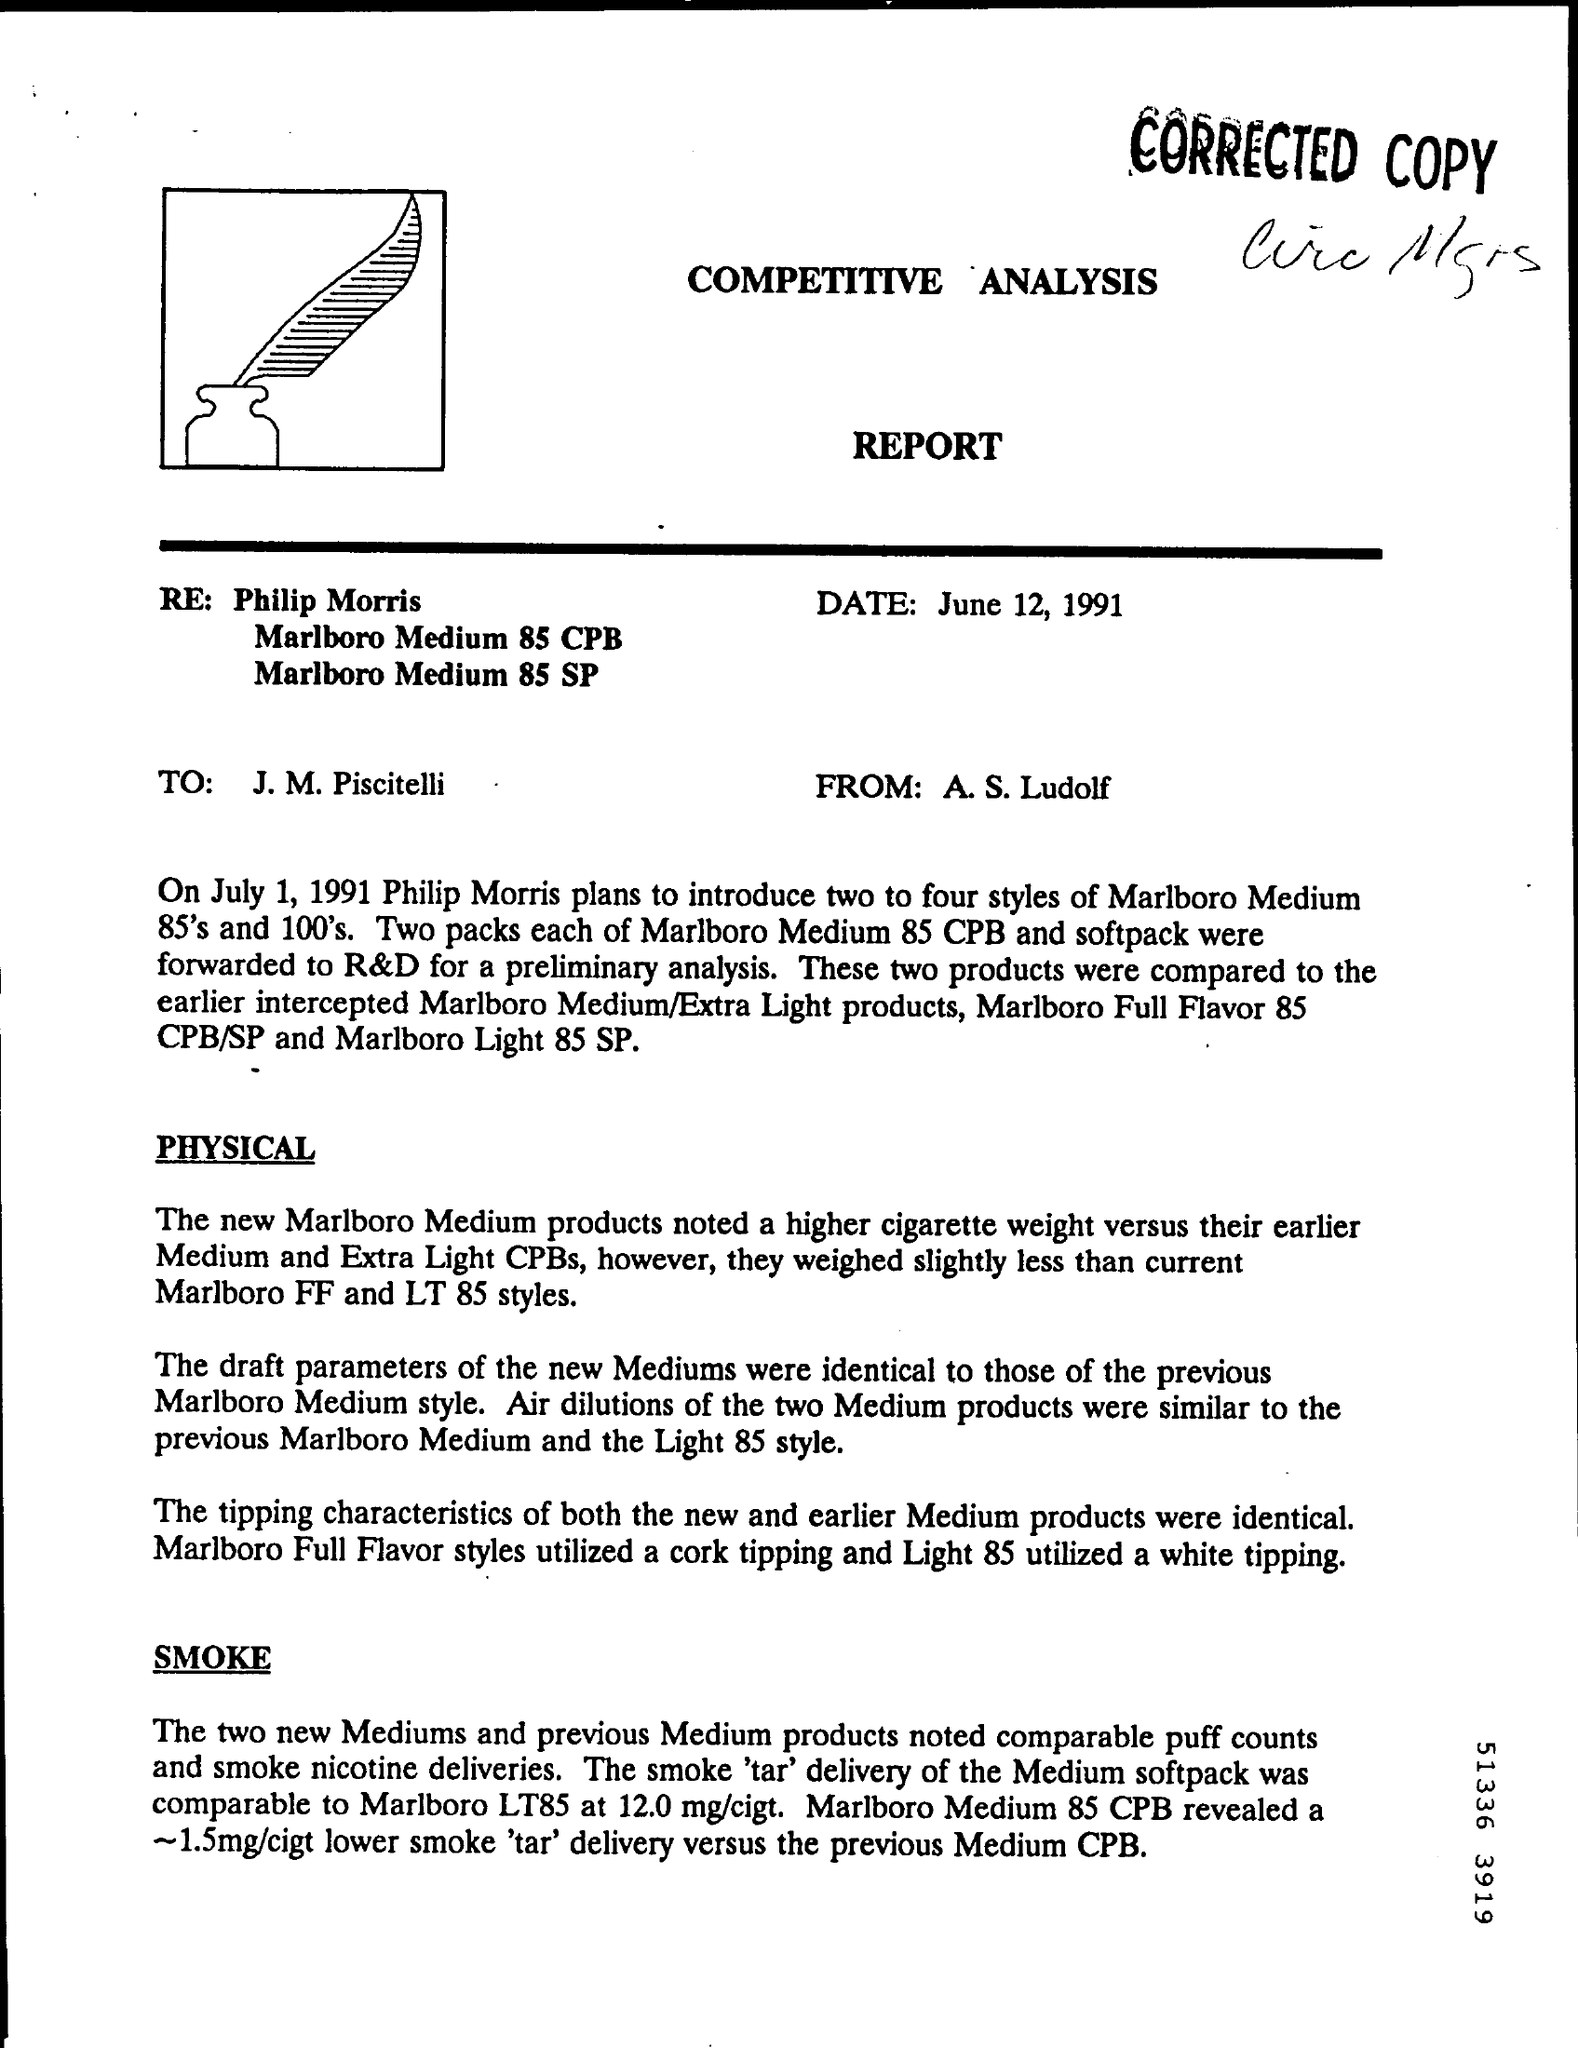Outline some significant characteristics in this image. The source of the report is S. Ludolf. The report is dated June 12th. The report is addressed to J. M. Piscitelli. 